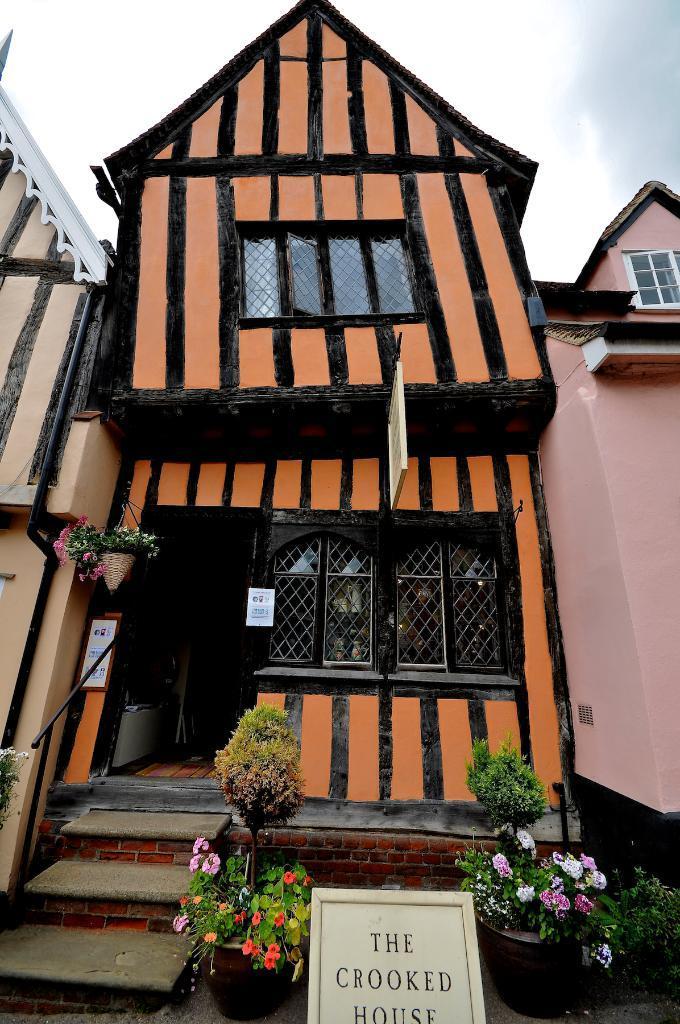Can you describe this image briefly? It's a house, it is in orange and black color. There are flower plants in front of this house. 